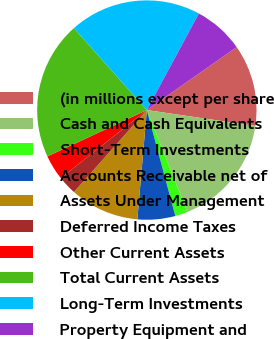Convert chart to OTSL. <chart><loc_0><loc_0><loc_500><loc_500><pie_chart><fcel>(in millions except per share<fcel>Cash and Cash Equivalents<fcel>Short-Term Investments<fcel>Accounts Receivable net of<fcel>Assets Under Management<fcel>Deferred Income Taxes<fcel>Other Current Assets<fcel>Total Current Assets<fcel>Long-Term Investments<fcel>Property Equipment and<nl><fcel>12.04%<fcel>16.66%<fcel>1.85%<fcel>5.56%<fcel>10.19%<fcel>2.78%<fcel>3.71%<fcel>20.37%<fcel>19.44%<fcel>7.41%<nl></chart> 